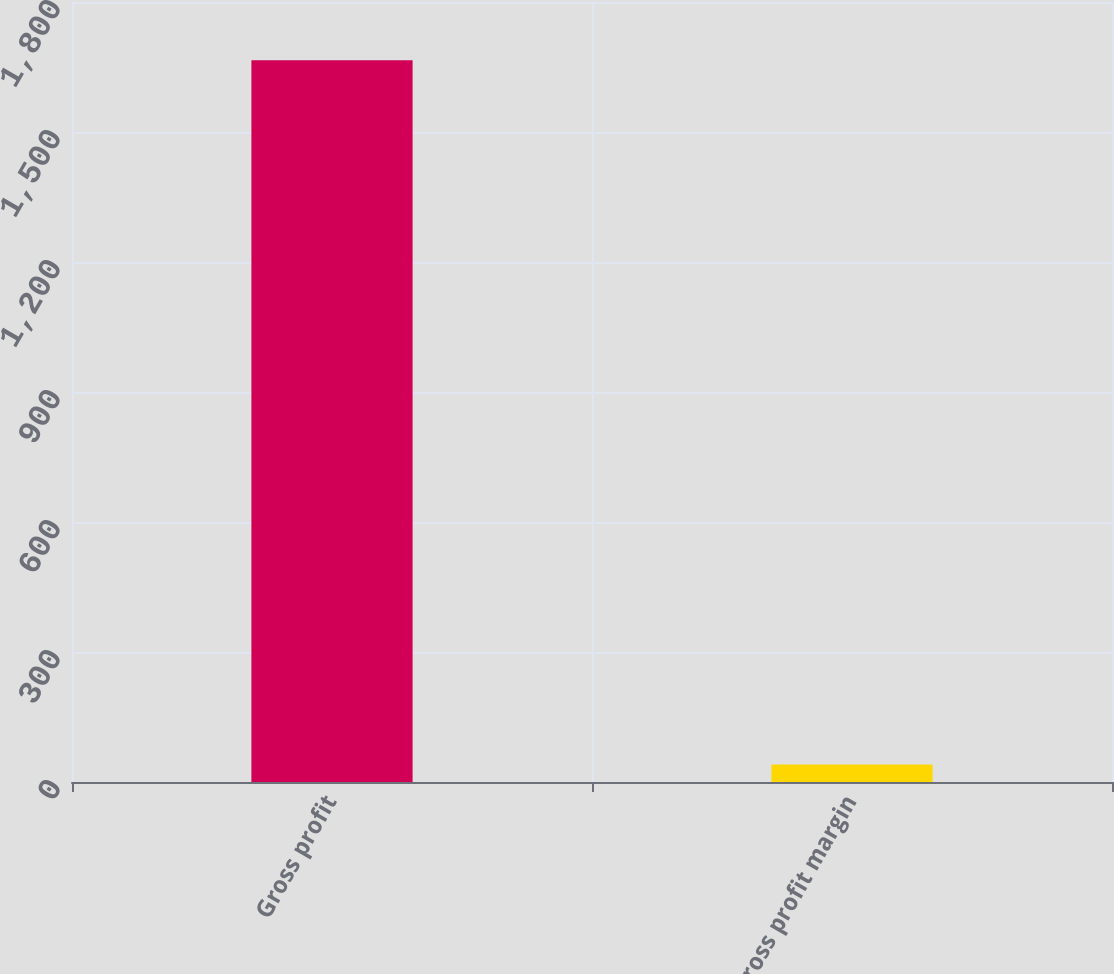Convert chart. <chart><loc_0><loc_0><loc_500><loc_500><bar_chart><fcel>Gross profit<fcel>Gross profit margin<nl><fcel>1665.8<fcel>40.4<nl></chart> 